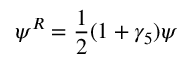<formula> <loc_0><loc_0><loc_500><loc_500>\psi ^ { R } = { \frac { 1 } { 2 } } ( 1 + \gamma _ { 5 } ) \psi</formula> 